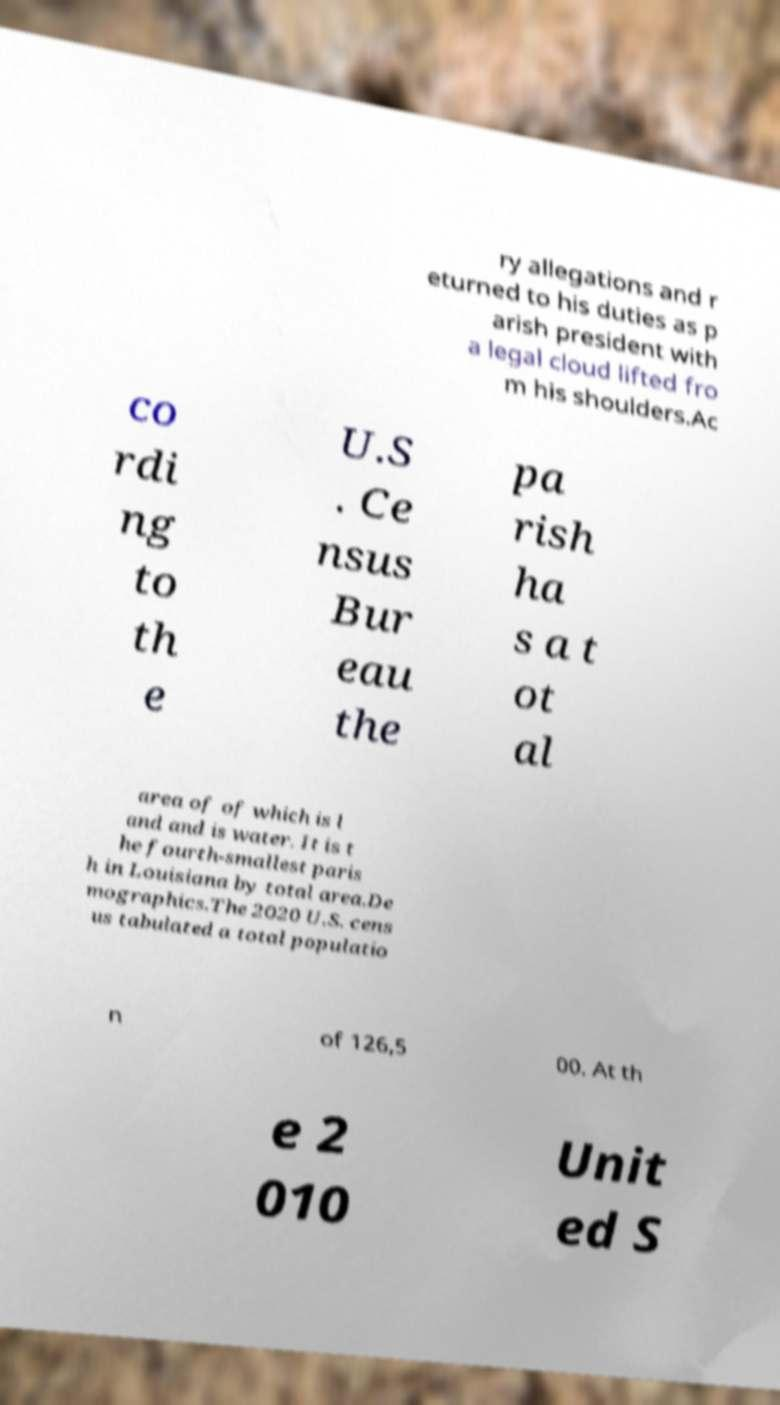Please read and relay the text visible in this image. What does it say? ry allegations and r eturned to his duties as p arish president with a legal cloud lifted fro m his shoulders.Ac co rdi ng to th e U.S . Ce nsus Bur eau the pa rish ha s a t ot al area of of which is l and and is water. It is t he fourth-smallest paris h in Louisiana by total area.De mographics.The 2020 U.S. cens us tabulated a total populatio n of 126,5 00. At th e 2 010 Unit ed S 